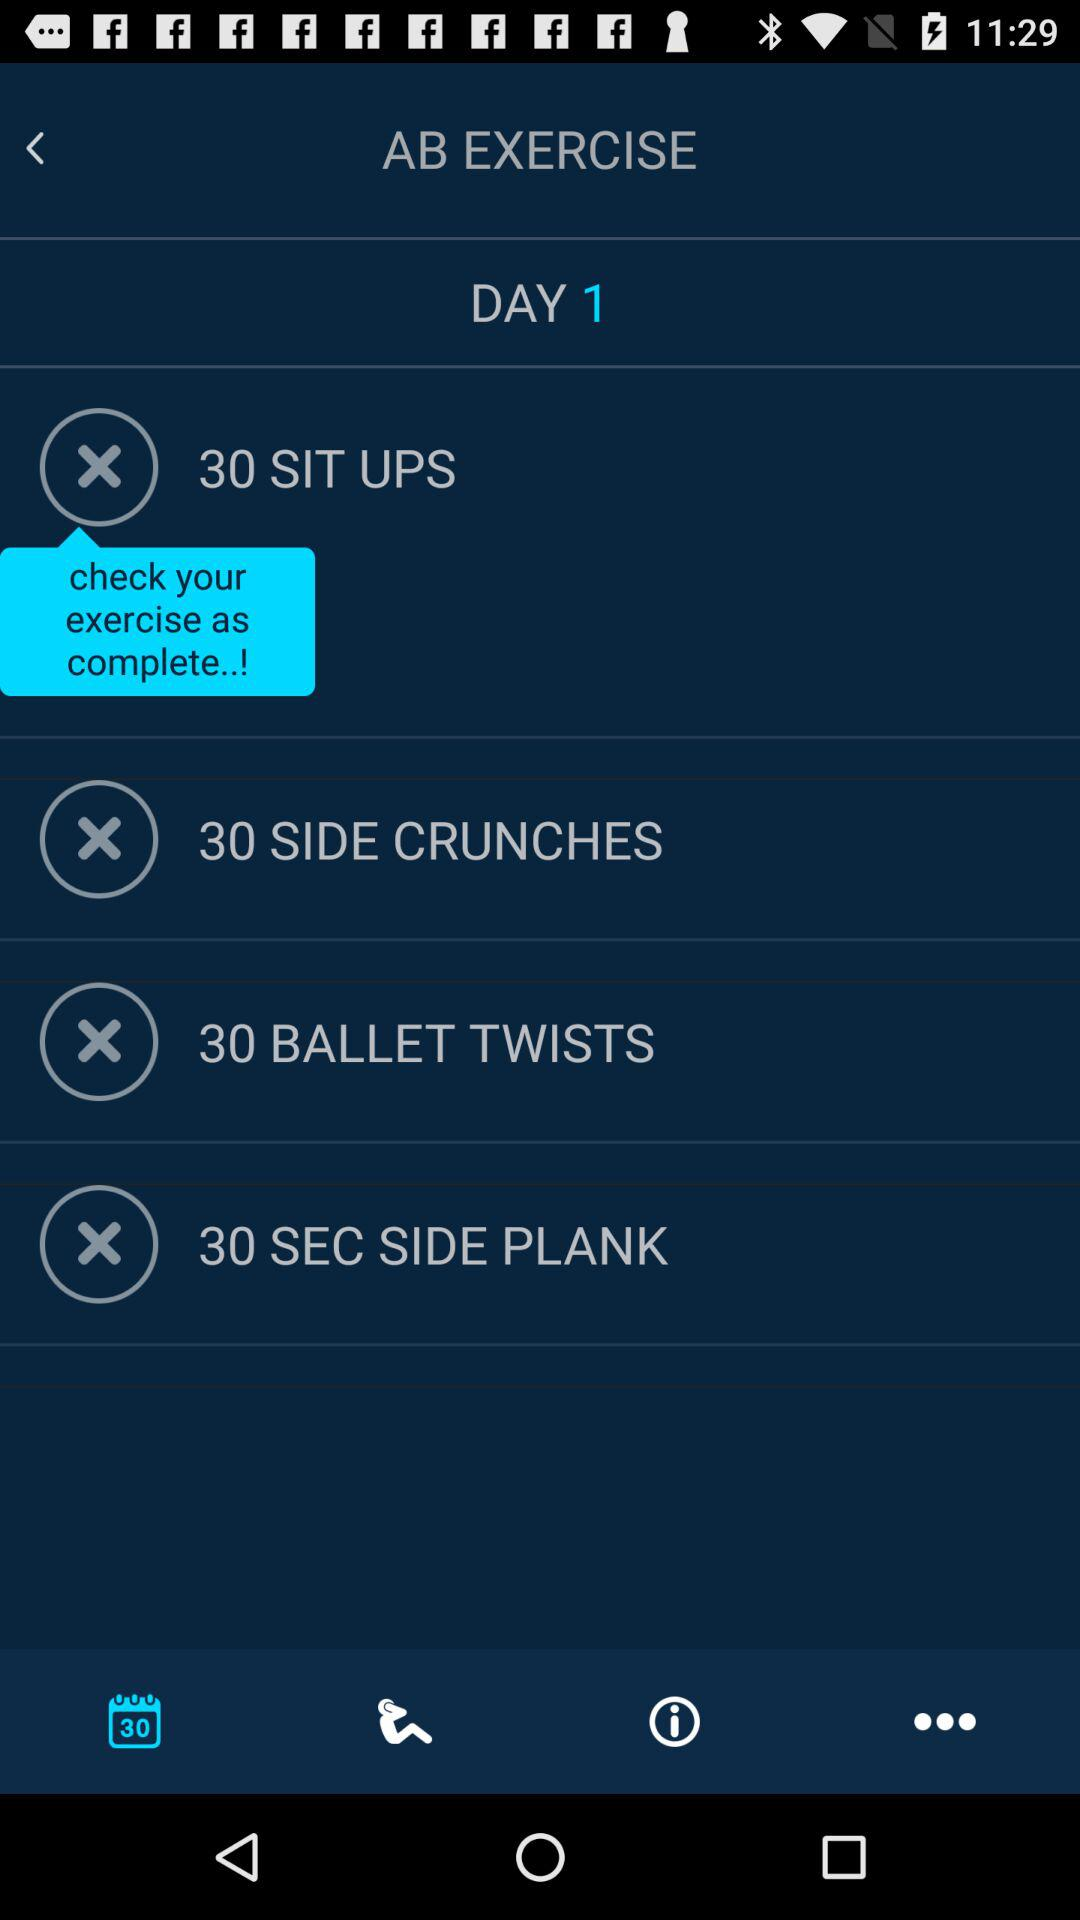For how many seconds "SIDE PLANK" should be done? "SIDE PLANK" should be done for 30 seconds. 